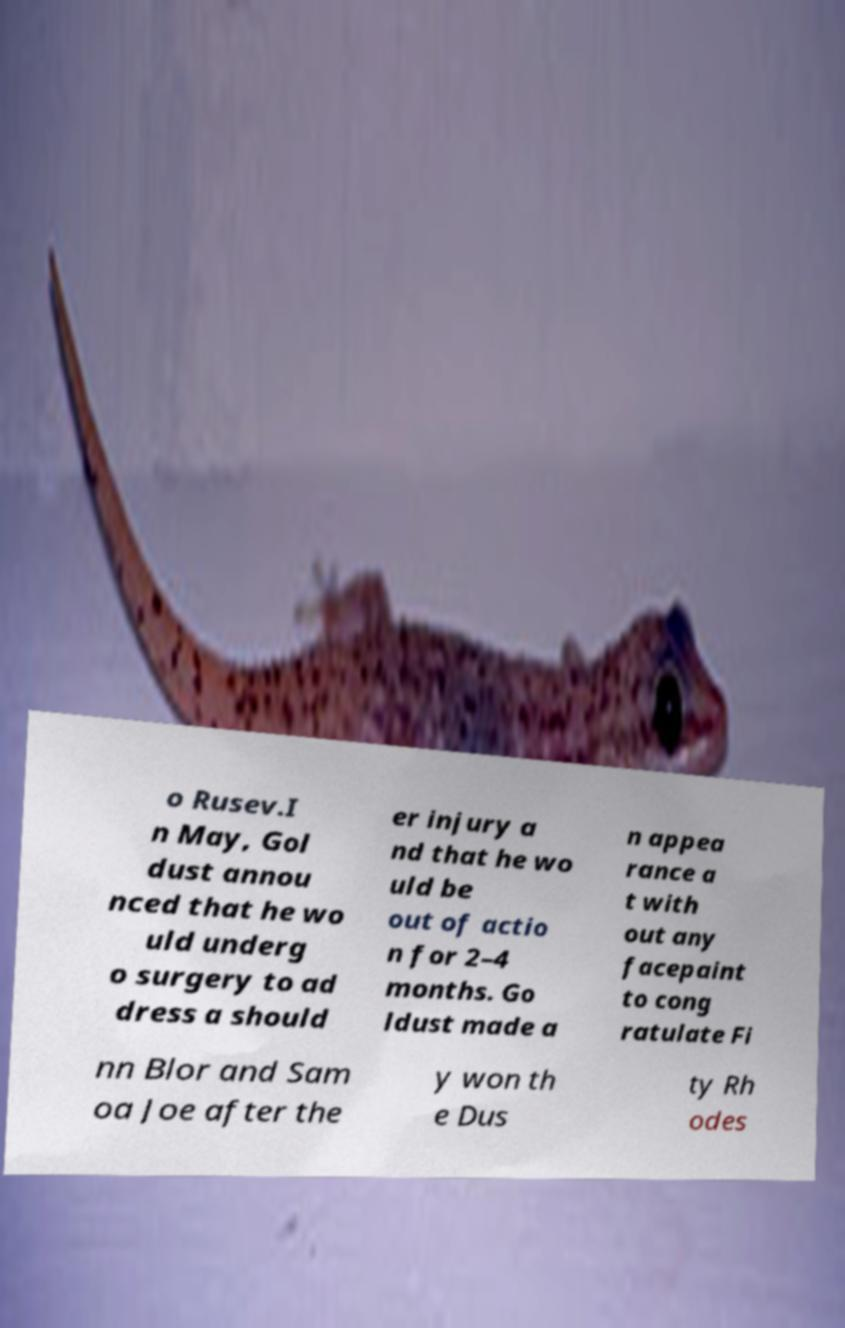For documentation purposes, I need the text within this image transcribed. Could you provide that? o Rusev.I n May, Gol dust annou nced that he wo uld underg o surgery to ad dress a should er injury a nd that he wo uld be out of actio n for 2–4 months. Go ldust made a n appea rance a t with out any facepaint to cong ratulate Fi nn Blor and Sam oa Joe after the y won th e Dus ty Rh odes 